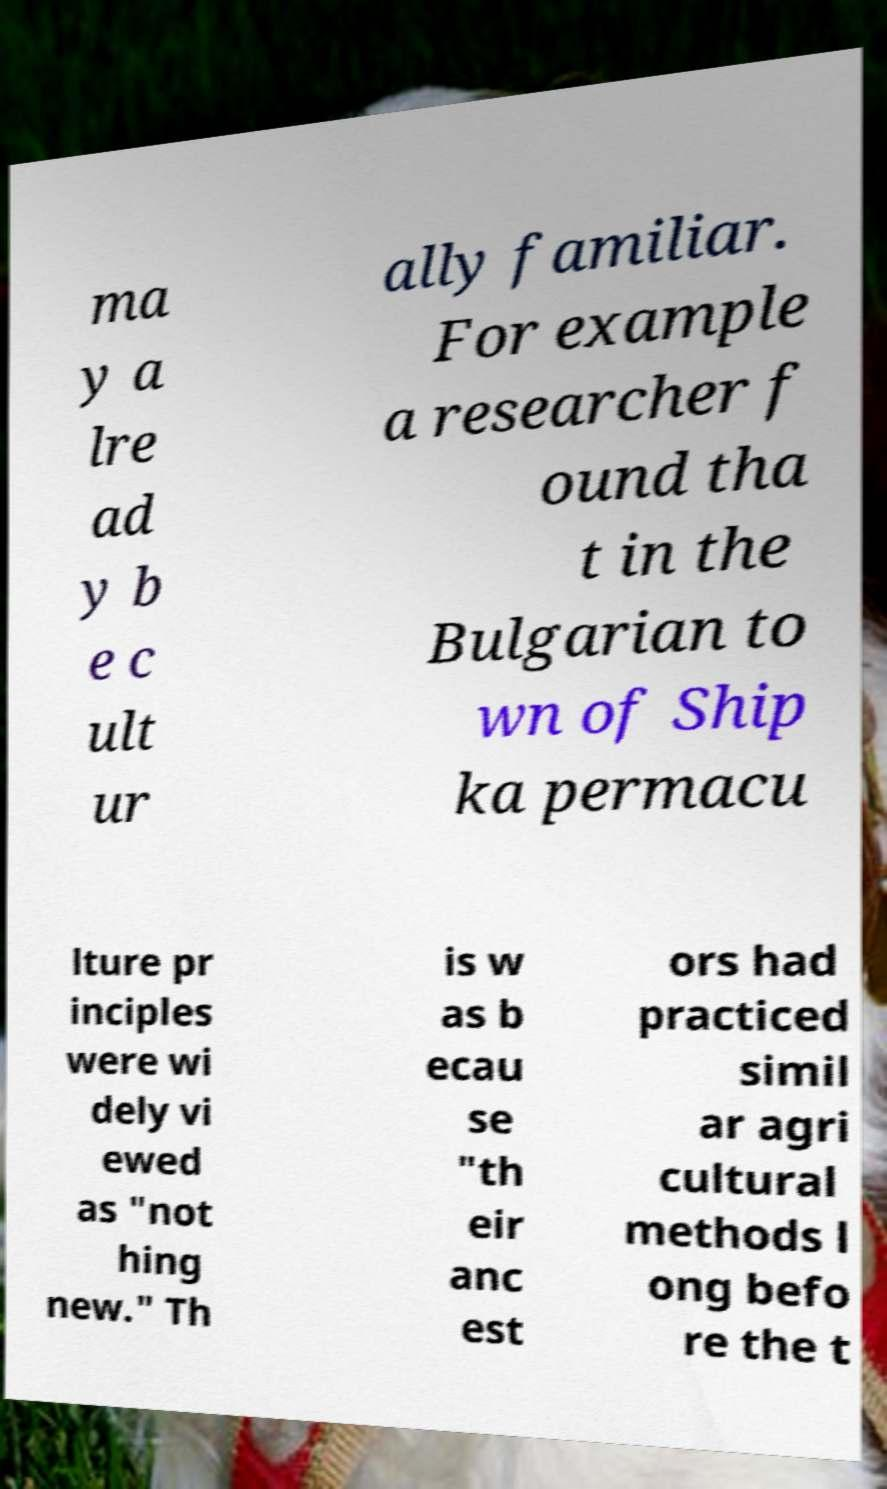What messages or text are displayed in this image? I need them in a readable, typed format. ma y a lre ad y b e c ult ur ally familiar. For example a researcher f ound tha t in the Bulgarian to wn of Ship ka permacu lture pr inciples were wi dely vi ewed as "not hing new." Th is w as b ecau se "th eir anc est ors had practiced simil ar agri cultural methods l ong befo re the t 